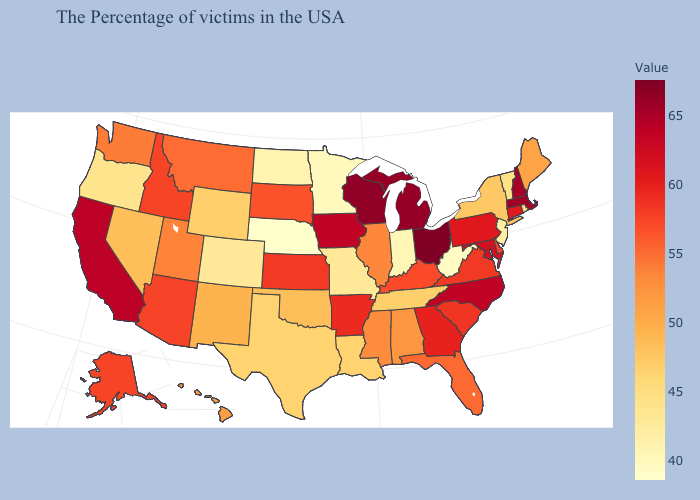Does Ohio have the highest value in the USA?
Quick response, please. Yes. Which states hav the highest value in the South?
Concise answer only. North Carolina. Which states have the highest value in the USA?
Keep it brief. Ohio. Is the legend a continuous bar?
Keep it brief. Yes. Among the states that border Georgia , which have the lowest value?
Quick response, please. Tennessee. Does Nevada have a lower value than Alaska?
Give a very brief answer. Yes. Which states have the lowest value in the Northeast?
Be succinct. New Jersey. Is the legend a continuous bar?
Keep it brief. Yes. 